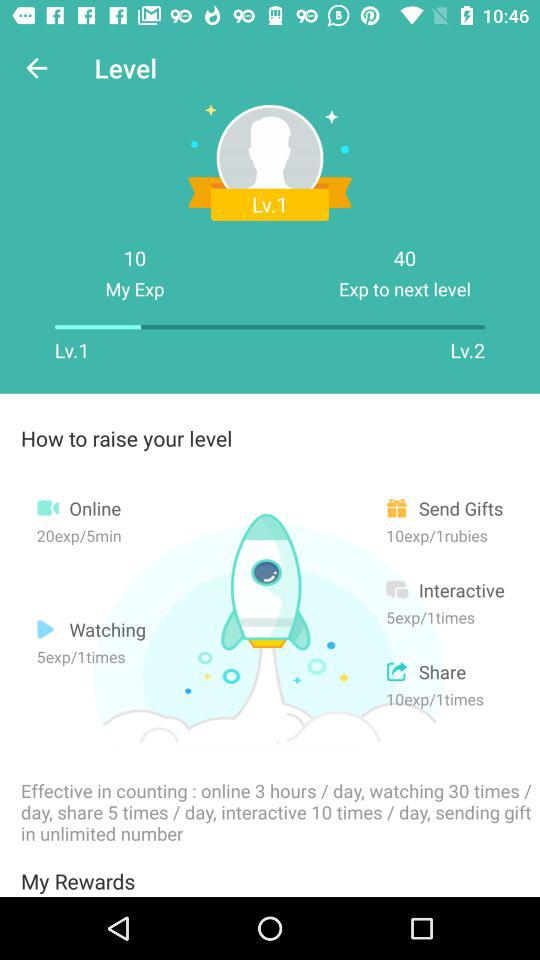How much experience can be gained in a 5-minute online call? The amount of experience that can be gained in a 5-minute online call is 20. 